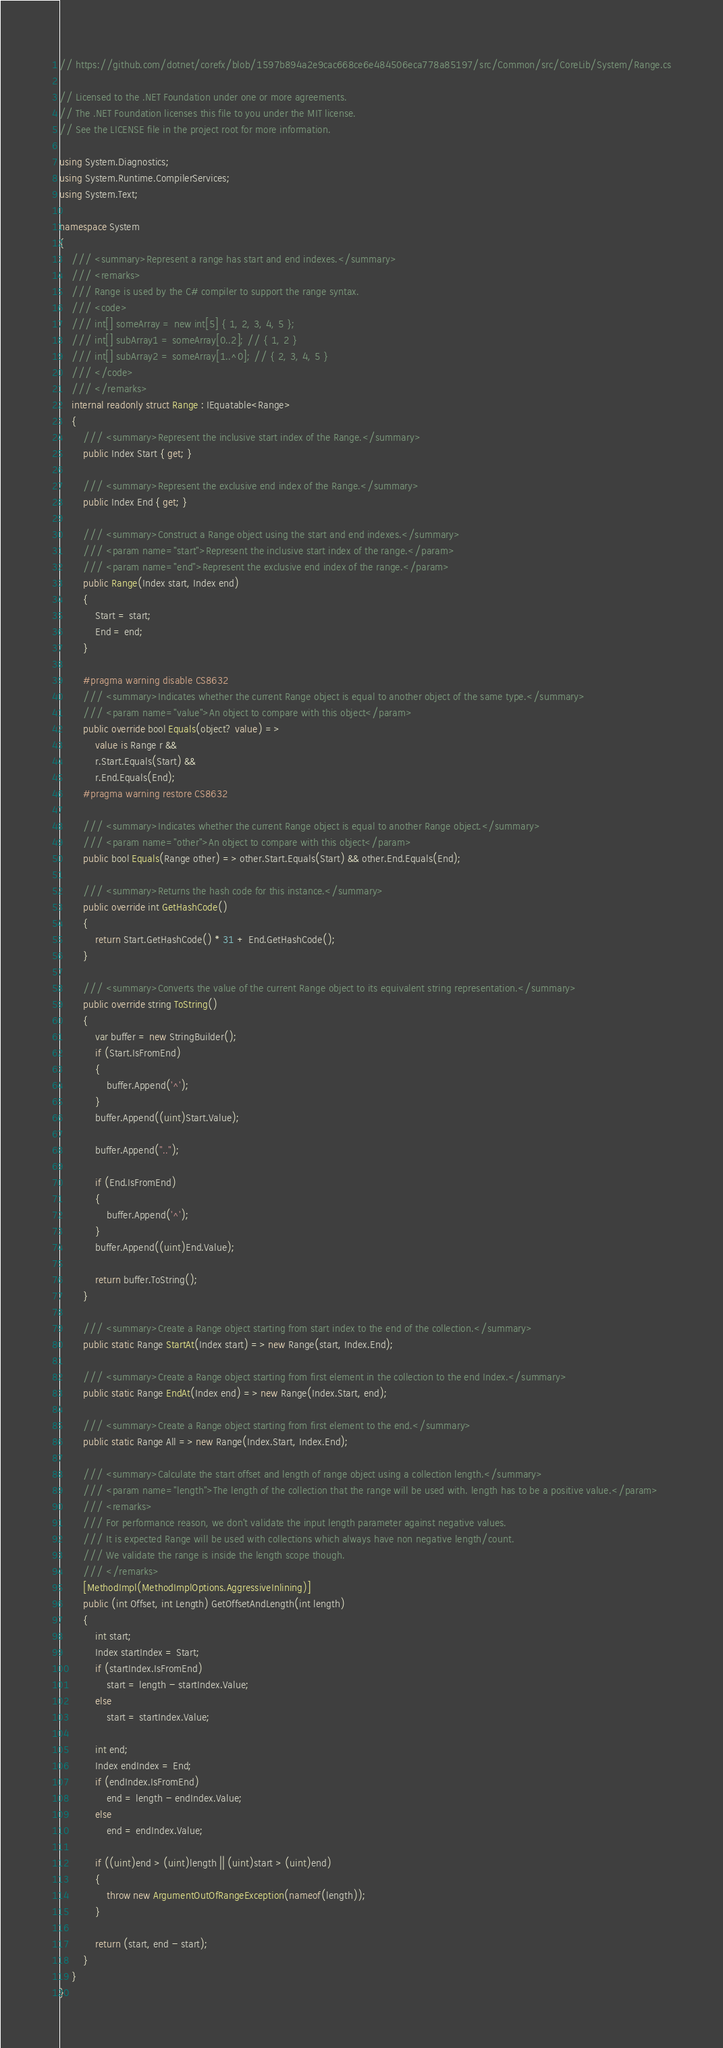<code> <loc_0><loc_0><loc_500><loc_500><_C#_>// https://github.com/dotnet/corefx/blob/1597b894a2e9cac668ce6e484506eca778a85197/src/Common/src/CoreLib/System/Range.cs

// Licensed to the .NET Foundation under one or more agreements.
// The .NET Foundation licenses this file to you under the MIT license.
// See the LICENSE file in the project root for more information.

using System.Diagnostics;
using System.Runtime.CompilerServices;
using System.Text;

namespace System
{
    /// <summary>Represent a range has start and end indexes.</summary>
    /// <remarks>
    /// Range is used by the C# compiler to support the range syntax.
    /// <code>
    /// int[] someArray = new int[5] { 1, 2, 3, 4, 5 };
    /// int[] subArray1 = someArray[0..2]; // { 1, 2 }
    /// int[] subArray2 = someArray[1..^0]; // { 2, 3, 4, 5 }
    /// </code>
    /// </remarks>
    internal readonly struct Range : IEquatable<Range>
    {
        /// <summary>Represent the inclusive start index of the Range.</summary>
        public Index Start { get; }

        /// <summary>Represent the exclusive end index of the Range.</summary>
        public Index End { get; }

        /// <summary>Construct a Range object using the start and end indexes.</summary>
        /// <param name="start">Represent the inclusive start index of the range.</param>
        /// <param name="end">Represent the exclusive end index of the range.</param>
        public Range(Index start, Index end)
        {
            Start = start;
            End = end;
        }

        #pragma warning disable CS8632
        /// <summary>Indicates whether the current Range object is equal to another object of the same type.</summary>
        /// <param name="value">An object to compare with this object</param>
        public override bool Equals(object? value) =>
            value is Range r &&
            r.Start.Equals(Start) &&
            r.End.Equals(End);
        #pragma warning restore CS8632

        /// <summary>Indicates whether the current Range object is equal to another Range object.</summary>
        /// <param name="other">An object to compare with this object</param>
        public bool Equals(Range other) => other.Start.Equals(Start) && other.End.Equals(End);

        /// <summary>Returns the hash code for this instance.</summary>
        public override int GetHashCode()
        {
            return Start.GetHashCode() * 31 + End.GetHashCode();
        }

        /// <summary>Converts the value of the current Range object to its equivalent string representation.</summary>
        public override string ToString()
        {
            var buffer = new StringBuilder();
            if (Start.IsFromEnd)
            {
                buffer.Append('^');
            }
            buffer.Append((uint)Start.Value);

            buffer.Append("..");

            if (End.IsFromEnd)
            {
                buffer.Append('^');
            }
            buffer.Append((uint)End.Value);

            return buffer.ToString();
        }

        /// <summary>Create a Range object starting from start index to the end of the collection.</summary>
        public static Range StartAt(Index start) => new Range(start, Index.End);

        /// <summary>Create a Range object starting from first element in the collection to the end Index.</summary>
        public static Range EndAt(Index end) => new Range(Index.Start, end);

        /// <summary>Create a Range object starting from first element to the end.</summary>
        public static Range All => new Range(Index.Start, Index.End);

        /// <summary>Calculate the start offset and length of range object using a collection length.</summary>
        /// <param name="length">The length of the collection that the range will be used with. length has to be a positive value.</param>
        /// <remarks>
        /// For performance reason, we don't validate the input length parameter against negative values.
        /// It is expected Range will be used with collections which always have non negative length/count.
        /// We validate the range is inside the length scope though.
        /// </remarks>
        [MethodImpl(MethodImplOptions.AggressiveInlining)]
        public (int Offset, int Length) GetOffsetAndLength(int length)
        {
            int start;
            Index startIndex = Start;
            if (startIndex.IsFromEnd)
                start = length - startIndex.Value;
            else
                start = startIndex.Value;

            int end;
            Index endIndex = End;
            if (endIndex.IsFromEnd)
                end = length - endIndex.Value;
            else
                end = endIndex.Value;

            if ((uint)end > (uint)length || (uint)start > (uint)end)
            {
                throw new ArgumentOutOfRangeException(nameof(length));
            }

            return (start, end - start);
        }
    }
}</code> 